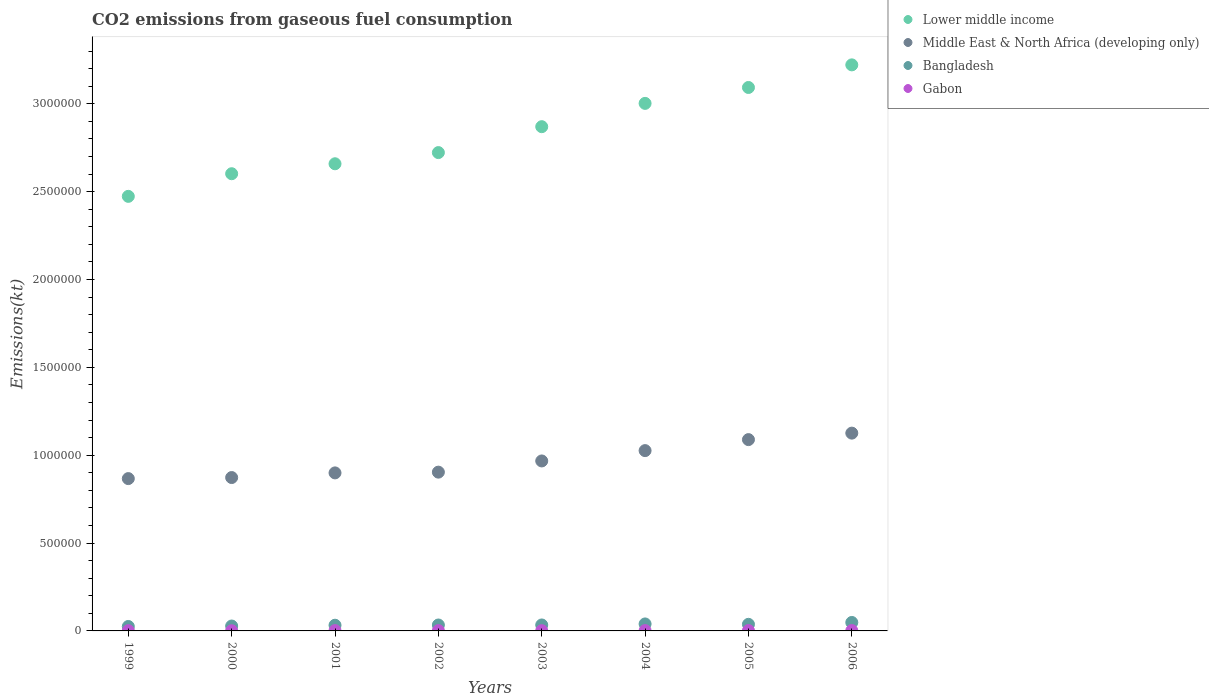Is the number of dotlines equal to the number of legend labels?
Make the answer very short. Yes. What is the amount of CO2 emitted in Bangladesh in 2003?
Your response must be concise. 3.39e+04. Across all years, what is the maximum amount of CO2 emitted in Bangladesh?
Give a very brief answer. 4.81e+04. Across all years, what is the minimum amount of CO2 emitted in Middle East & North Africa (developing only)?
Your response must be concise. 8.67e+05. In which year was the amount of CO2 emitted in Gabon minimum?
Offer a very short reply. 2000. What is the total amount of CO2 emitted in Gabon in the graph?
Give a very brief answer. 1.36e+04. What is the difference between the amount of CO2 emitted in Bangladesh in 1999 and that in 2006?
Your answer should be compact. -2.29e+04. What is the difference between the amount of CO2 emitted in Lower middle income in 2006 and the amount of CO2 emitted in Bangladesh in 2003?
Ensure brevity in your answer.  3.19e+06. What is the average amount of CO2 emitted in Bangladesh per year?
Give a very brief answer. 3.48e+04. In the year 2005, what is the difference between the amount of CO2 emitted in Bangladesh and amount of CO2 emitted in Middle East & North Africa (developing only)?
Offer a terse response. -1.05e+06. What is the ratio of the amount of CO2 emitted in Gabon in 1999 to that in 2004?
Offer a very short reply. 0.78. Is the difference between the amount of CO2 emitted in Bangladesh in 1999 and 2004 greater than the difference between the amount of CO2 emitted in Middle East & North Africa (developing only) in 1999 and 2004?
Provide a succinct answer. Yes. What is the difference between the highest and the second highest amount of CO2 emitted in Bangladesh?
Give a very brief answer. 8386.43. What is the difference between the highest and the lowest amount of CO2 emitted in Lower middle income?
Provide a succinct answer. 7.48e+05. How many years are there in the graph?
Your answer should be compact. 8. What is the difference between two consecutive major ticks on the Y-axis?
Make the answer very short. 5.00e+05. Does the graph contain any zero values?
Offer a very short reply. No. What is the title of the graph?
Provide a succinct answer. CO2 emissions from gaseous fuel consumption. Does "New Zealand" appear as one of the legend labels in the graph?
Your answer should be very brief. No. What is the label or title of the Y-axis?
Provide a short and direct response. Emissions(kt). What is the Emissions(kt) of Lower middle income in 1999?
Your answer should be very brief. 2.47e+06. What is the Emissions(kt) of Middle East & North Africa (developing only) in 1999?
Provide a succinct answer. 8.67e+05. What is the Emissions(kt) in Bangladesh in 1999?
Your answer should be compact. 2.52e+04. What is the Emissions(kt) in Gabon in 1999?
Your response must be concise. 1437.46. What is the Emissions(kt) of Lower middle income in 2000?
Your answer should be compact. 2.60e+06. What is the Emissions(kt) of Middle East & North Africa (developing only) in 2000?
Keep it short and to the point. 8.73e+05. What is the Emissions(kt) in Bangladesh in 2000?
Give a very brief answer. 2.79e+04. What is the Emissions(kt) in Gabon in 2000?
Make the answer very short. 1052.43. What is the Emissions(kt) of Lower middle income in 2001?
Ensure brevity in your answer.  2.66e+06. What is the Emissions(kt) of Middle East & North Africa (developing only) in 2001?
Offer a very short reply. 8.99e+05. What is the Emissions(kt) of Bangladesh in 2001?
Your response must be concise. 3.25e+04. What is the Emissions(kt) in Gabon in 2001?
Provide a succinct answer. 1782.16. What is the Emissions(kt) in Lower middle income in 2002?
Your answer should be compact. 2.72e+06. What is the Emissions(kt) in Middle East & North Africa (developing only) in 2002?
Your answer should be compact. 9.04e+05. What is the Emissions(kt) in Bangladesh in 2002?
Provide a short and direct response. 3.37e+04. What is the Emissions(kt) in Gabon in 2002?
Your answer should be compact. 1778.49. What is the Emissions(kt) in Lower middle income in 2003?
Give a very brief answer. 2.87e+06. What is the Emissions(kt) in Middle East & North Africa (developing only) in 2003?
Keep it short and to the point. 9.67e+05. What is the Emissions(kt) in Bangladesh in 2003?
Your answer should be very brief. 3.39e+04. What is the Emissions(kt) in Gabon in 2003?
Your answer should be very brief. 1441.13. What is the Emissions(kt) of Lower middle income in 2004?
Provide a short and direct response. 3.00e+06. What is the Emissions(kt) of Middle East & North Africa (developing only) in 2004?
Offer a very short reply. 1.03e+06. What is the Emissions(kt) in Bangladesh in 2004?
Your response must be concise. 3.98e+04. What is the Emissions(kt) of Gabon in 2004?
Ensure brevity in your answer.  1851.84. What is the Emissions(kt) in Lower middle income in 2005?
Give a very brief answer. 3.09e+06. What is the Emissions(kt) in Middle East & North Africa (developing only) in 2005?
Ensure brevity in your answer.  1.09e+06. What is the Emissions(kt) in Bangladesh in 2005?
Keep it short and to the point. 3.76e+04. What is the Emissions(kt) in Gabon in 2005?
Give a very brief answer. 2174.53. What is the Emissions(kt) of Lower middle income in 2006?
Offer a very short reply. 3.22e+06. What is the Emissions(kt) in Middle East & North Africa (developing only) in 2006?
Ensure brevity in your answer.  1.13e+06. What is the Emissions(kt) in Bangladesh in 2006?
Provide a succinct answer. 4.81e+04. What is the Emissions(kt) in Gabon in 2006?
Ensure brevity in your answer.  2082.86. Across all years, what is the maximum Emissions(kt) in Lower middle income?
Give a very brief answer. 3.22e+06. Across all years, what is the maximum Emissions(kt) in Middle East & North Africa (developing only)?
Provide a short and direct response. 1.13e+06. Across all years, what is the maximum Emissions(kt) of Bangladesh?
Ensure brevity in your answer.  4.81e+04. Across all years, what is the maximum Emissions(kt) of Gabon?
Your response must be concise. 2174.53. Across all years, what is the minimum Emissions(kt) of Lower middle income?
Offer a very short reply. 2.47e+06. Across all years, what is the minimum Emissions(kt) in Middle East & North Africa (developing only)?
Your answer should be compact. 8.67e+05. Across all years, what is the minimum Emissions(kt) in Bangladesh?
Ensure brevity in your answer.  2.52e+04. Across all years, what is the minimum Emissions(kt) in Gabon?
Offer a terse response. 1052.43. What is the total Emissions(kt) in Lower middle income in the graph?
Make the answer very short. 2.26e+07. What is the total Emissions(kt) in Middle East & North Africa (developing only) in the graph?
Ensure brevity in your answer.  7.75e+06. What is the total Emissions(kt) in Bangladesh in the graph?
Ensure brevity in your answer.  2.79e+05. What is the total Emissions(kt) of Gabon in the graph?
Your answer should be compact. 1.36e+04. What is the difference between the Emissions(kt) of Lower middle income in 1999 and that in 2000?
Ensure brevity in your answer.  -1.29e+05. What is the difference between the Emissions(kt) in Middle East & North Africa (developing only) in 1999 and that in 2000?
Keep it short and to the point. -5958.88. What is the difference between the Emissions(kt) in Bangladesh in 1999 and that in 2000?
Your answer should be very brief. -2632.91. What is the difference between the Emissions(kt) in Gabon in 1999 and that in 2000?
Make the answer very short. 385.04. What is the difference between the Emissions(kt) in Lower middle income in 1999 and that in 2001?
Ensure brevity in your answer.  -1.85e+05. What is the difference between the Emissions(kt) in Middle East & North Africa (developing only) in 1999 and that in 2001?
Your answer should be compact. -3.24e+04. What is the difference between the Emissions(kt) in Bangladesh in 1999 and that in 2001?
Offer a terse response. -7220.32. What is the difference between the Emissions(kt) of Gabon in 1999 and that in 2001?
Give a very brief answer. -344.7. What is the difference between the Emissions(kt) in Lower middle income in 1999 and that in 2002?
Provide a short and direct response. -2.49e+05. What is the difference between the Emissions(kt) of Middle East & North Africa (developing only) in 1999 and that in 2002?
Your answer should be very brief. -3.67e+04. What is the difference between the Emissions(kt) in Bangladesh in 1999 and that in 2002?
Provide a succinct answer. -8470.77. What is the difference between the Emissions(kt) of Gabon in 1999 and that in 2002?
Your answer should be compact. -341.03. What is the difference between the Emissions(kt) of Lower middle income in 1999 and that in 2003?
Offer a very short reply. -3.97e+05. What is the difference between the Emissions(kt) of Middle East & North Africa (developing only) in 1999 and that in 2003?
Provide a short and direct response. -1.00e+05. What is the difference between the Emissions(kt) in Bangladesh in 1999 and that in 2003?
Your response must be concise. -8646.79. What is the difference between the Emissions(kt) in Gabon in 1999 and that in 2003?
Your answer should be compact. -3.67. What is the difference between the Emissions(kt) of Lower middle income in 1999 and that in 2004?
Keep it short and to the point. -5.29e+05. What is the difference between the Emissions(kt) in Middle East & North Africa (developing only) in 1999 and that in 2004?
Provide a succinct answer. -1.59e+05. What is the difference between the Emissions(kt) of Bangladesh in 1999 and that in 2004?
Your response must be concise. -1.45e+04. What is the difference between the Emissions(kt) of Gabon in 1999 and that in 2004?
Your response must be concise. -414.37. What is the difference between the Emissions(kt) of Lower middle income in 1999 and that in 2005?
Provide a short and direct response. -6.20e+05. What is the difference between the Emissions(kt) of Middle East & North Africa (developing only) in 1999 and that in 2005?
Provide a short and direct response. -2.22e+05. What is the difference between the Emissions(kt) of Bangladesh in 1999 and that in 2005?
Give a very brief answer. -1.23e+04. What is the difference between the Emissions(kt) of Gabon in 1999 and that in 2005?
Offer a terse response. -737.07. What is the difference between the Emissions(kt) of Lower middle income in 1999 and that in 2006?
Your answer should be very brief. -7.48e+05. What is the difference between the Emissions(kt) of Middle East & North Africa (developing only) in 1999 and that in 2006?
Offer a very short reply. -2.59e+05. What is the difference between the Emissions(kt) of Bangladesh in 1999 and that in 2006?
Ensure brevity in your answer.  -2.29e+04. What is the difference between the Emissions(kt) in Gabon in 1999 and that in 2006?
Make the answer very short. -645.39. What is the difference between the Emissions(kt) of Lower middle income in 2000 and that in 2001?
Your answer should be compact. -5.67e+04. What is the difference between the Emissions(kt) in Middle East & North Africa (developing only) in 2000 and that in 2001?
Provide a succinct answer. -2.65e+04. What is the difference between the Emissions(kt) in Bangladesh in 2000 and that in 2001?
Your answer should be compact. -4587.42. What is the difference between the Emissions(kt) of Gabon in 2000 and that in 2001?
Make the answer very short. -729.73. What is the difference between the Emissions(kt) in Lower middle income in 2000 and that in 2002?
Make the answer very short. -1.20e+05. What is the difference between the Emissions(kt) in Middle East & North Africa (developing only) in 2000 and that in 2002?
Provide a succinct answer. -3.08e+04. What is the difference between the Emissions(kt) in Bangladesh in 2000 and that in 2002?
Give a very brief answer. -5837.86. What is the difference between the Emissions(kt) in Gabon in 2000 and that in 2002?
Give a very brief answer. -726.07. What is the difference between the Emissions(kt) in Lower middle income in 2000 and that in 2003?
Your answer should be compact. -2.68e+05. What is the difference between the Emissions(kt) of Middle East & North Africa (developing only) in 2000 and that in 2003?
Make the answer very short. -9.45e+04. What is the difference between the Emissions(kt) of Bangladesh in 2000 and that in 2003?
Provide a short and direct response. -6013.88. What is the difference between the Emissions(kt) of Gabon in 2000 and that in 2003?
Ensure brevity in your answer.  -388.7. What is the difference between the Emissions(kt) in Lower middle income in 2000 and that in 2004?
Give a very brief answer. -4.00e+05. What is the difference between the Emissions(kt) of Middle East & North Africa (developing only) in 2000 and that in 2004?
Provide a succinct answer. -1.53e+05. What is the difference between the Emissions(kt) of Bangladesh in 2000 and that in 2004?
Offer a very short reply. -1.19e+04. What is the difference between the Emissions(kt) of Gabon in 2000 and that in 2004?
Make the answer very short. -799.41. What is the difference between the Emissions(kt) of Lower middle income in 2000 and that in 2005?
Keep it short and to the point. -4.91e+05. What is the difference between the Emissions(kt) of Middle East & North Africa (developing only) in 2000 and that in 2005?
Your answer should be very brief. -2.16e+05. What is the difference between the Emissions(kt) of Bangladesh in 2000 and that in 2005?
Keep it short and to the point. -9684.55. What is the difference between the Emissions(kt) in Gabon in 2000 and that in 2005?
Your answer should be compact. -1122.1. What is the difference between the Emissions(kt) of Lower middle income in 2000 and that in 2006?
Ensure brevity in your answer.  -6.20e+05. What is the difference between the Emissions(kt) in Middle East & North Africa (developing only) in 2000 and that in 2006?
Offer a terse response. -2.53e+05. What is the difference between the Emissions(kt) of Bangladesh in 2000 and that in 2006?
Ensure brevity in your answer.  -2.03e+04. What is the difference between the Emissions(kt) in Gabon in 2000 and that in 2006?
Keep it short and to the point. -1030.43. What is the difference between the Emissions(kt) in Lower middle income in 2001 and that in 2002?
Your answer should be compact. -6.36e+04. What is the difference between the Emissions(kt) of Middle East & North Africa (developing only) in 2001 and that in 2002?
Offer a very short reply. -4283.06. What is the difference between the Emissions(kt) of Bangladesh in 2001 and that in 2002?
Ensure brevity in your answer.  -1250.45. What is the difference between the Emissions(kt) of Gabon in 2001 and that in 2002?
Your answer should be very brief. 3.67. What is the difference between the Emissions(kt) of Lower middle income in 2001 and that in 2003?
Keep it short and to the point. -2.11e+05. What is the difference between the Emissions(kt) in Middle East & North Africa (developing only) in 2001 and that in 2003?
Your answer should be compact. -6.80e+04. What is the difference between the Emissions(kt) in Bangladesh in 2001 and that in 2003?
Keep it short and to the point. -1426.46. What is the difference between the Emissions(kt) in Gabon in 2001 and that in 2003?
Ensure brevity in your answer.  341.03. What is the difference between the Emissions(kt) of Lower middle income in 2001 and that in 2004?
Offer a terse response. -3.44e+05. What is the difference between the Emissions(kt) in Middle East & North Africa (developing only) in 2001 and that in 2004?
Your answer should be compact. -1.27e+05. What is the difference between the Emissions(kt) of Bangladesh in 2001 and that in 2004?
Your response must be concise. -7293.66. What is the difference between the Emissions(kt) of Gabon in 2001 and that in 2004?
Provide a short and direct response. -69.67. What is the difference between the Emissions(kt) in Lower middle income in 2001 and that in 2005?
Your response must be concise. -4.34e+05. What is the difference between the Emissions(kt) in Middle East & North Africa (developing only) in 2001 and that in 2005?
Offer a terse response. -1.89e+05. What is the difference between the Emissions(kt) in Bangladesh in 2001 and that in 2005?
Your answer should be compact. -5097.13. What is the difference between the Emissions(kt) in Gabon in 2001 and that in 2005?
Make the answer very short. -392.37. What is the difference between the Emissions(kt) of Lower middle income in 2001 and that in 2006?
Your answer should be compact. -5.63e+05. What is the difference between the Emissions(kt) in Middle East & North Africa (developing only) in 2001 and that in 2006?
Make the answer very short. -2.26e+05. What is the difference between the Emissions(kt) in Bangladesh in 2001 and that in 2006?
Give a very brief answer. -1.57e+04. What is the difference between the Emissions(kt) of Gabon in 2001 and that in 2006?
Your answer should be compact. -300.69. What is the difference between the Emissions(kt) in Lower middle income in 2002 and that in 2003?
Your answer should be very brief. -1.47e+05. What is the difference between the Emissions(kt) of Middle East & North Africa (developing only) in 2002 and that in 2003?
Make the answer very short. -6.37e+04. What is the difference between the Emissions(kt) in Bangladesh in 2002 and that in 2003?
Provide a short and direct response. -176.02. What is the difference between the Emissions(kt) in Gabon in 2002 and that in 2003?
Ensure brevity in your answer.  337.36. What is the difference between the Emissions(kt) of Lower middle income in 2002 and that in 2004?
Provide a short and direct response. -2.80e+05. What is the difference between the Emissions(kt) in Middle East & North Africa (developing only) in 2002 and that in 2004?
Your response must be concise. -1.23e+05. What is the difference between the Emissions(kt) in Bangladesh in 2002 and that in 2004?
Offer a very short reply. -6043.22. What is the difference between the Emissions(kt) in Gabon in 2002 and that in 2004?
Make the answer very short. -73.34. What is the difference between the Emissions(kt) in Lower middle income in 2002 and that in 2005?
Your answer should be very brief. -3.71e+05. What is the difference between the Emissions(kt) in Middle East & North Africa (developing only) in 2002 and that in 2005?
Your answer should be very brief. -1.85e+05. What is the difference between the Emissions(kt) in Bangladesh in 2002 and that in 2005?
Your answer should be very brief. -3846.68. What is the difference between the Emissions(kt) in Gabon in 2002 and that in 2005?
Make the answer very short. -396.04. What is the difference between the Emissions(kt) of Lower middle income in 2002 and that in 2006?
Make the answer very short. -4.99e+05. What is the difference between the Emissions(kt) in Middle East & North Africa (developing only) in 2002 and that in 2006?
Make the answer very short. -2.22e+05. What is the difference between the Emissions(kt) of Bangladesh in 2002 and that in 2006?
Provide a short and direct response. -1.44e+04. What is the difference between the Emissions(kt) of Gabon in 2002 and that in 2006?
Make the answer very short. -304.36. What is the difference between the Emissions(kt) of Lower middle income in 2003 and that in 2004?
Offer a terse response. -1.33e+05. What is the difference between the Emissions(kt) of Middle East & North Africa (developing only) in 2003 and that in 2004?
Offer a terse response. -5.88e+04. What is the difference between the Emissions(kt) in Bangladesh in 2003 and that in 2004?
Keep it short and to the point. -5867.2. What is the difference between the Emissions(kt) of Gabon in 2003 and that in 2004?
Make the answer very short. -410.7. What is the difference between the Emissions(kt) in Lower middle income in 2003 and that in 2005?
Offer a very short reply. -2.23e+05. What is the difference between the Emissions(kt) in Middle East & North Africa (developing only) in 2003 and that in 2005?
Provide a succinct answer. -1.21e+05. What is the difference between the Emissions(kt) in Bangladesh in 2003 and that in 2005?
Your response must be concise. -3670.67. What is the difference between the Emissions(kt) of Gabon in 2003 and that in 2005?
Keep it short and to the point. -733.4. What is the difference between the Emissions(kt) in Lower middle income in 2003 and that in 2006?
Give a very brief answer. -3.52e+05. What is the difference between the Emissions(kt) in Middle East & North Africa (developing only) in 2003 and that in 2006?
Keep it short and to the point. -1.58e+05. What is the difference between the Emissions(kt) in Bangladesh in 2003 and that in 2006?
Keep it short and to the point. -1.43e+04. What is the difference between the Emissions(kt) in Gabon in 2003 and that in 2006?
Give a very brief answer. -641.73. What is the difference between the Emissions(kt) in Lower middle income in 2004 and that in 2005?
Provide a short and direct response. -9.05e+04. What is the difference between the Emissions(kt) of Middle East & North Africa (developing only) in 2004 and that in 2005?
Give a very brief answer. -6.26e+04. What is the difference between the Emissions(kt) in Bangladesh in 2004 and that in 2005?
Offer a very short reply. 2196.53. What is the difference between the Emissions(kt) in Gabon in 2004 and that in 2005?
Make the answer very short. -322.7. What is the difference between the Emissions(kt) in Lower middle income in 2004 and that in 2006?
Your answer should be very brief. -2.19e+05. What is the difference between the Emissions(kt) in Middle East & North Africa (developing only) in 2004 and that in 2006?
Offer a terse response. -9.95e+04. What is the difference between the Emissions(kt) in Bangladesh in 2004 and that in 2006?
Offer a terse response. -8386.43. What is the difference between the Emissions(kt) of Gabon in 2004 and that in 2006?
Your response must be concise. -231.02. What is the difference between the Emissions(kt) in Lower middle income in 2005 and that in 2006?
Your answer should be very brief. -1.29e+05. What is the difference between the Emissions(kt) in Middle East & North Africa (developing only) in 2005 and that in 2006?
Keep it short and to the point. -3.69e+04. What is the difference between the Emissions(kt) of Bangladesh in 2005 and that in 2006?
Offer a very short reply. -1.06e+04. What is the difference between the Emissions(kt) of Gabon in 2005 and that in 2006?
Offer a terse response. 91.67. What is the difference between the Emissions(kt) in Lower middle income in 1999 and the Emissions(kt) in Middle East & North Africa (developing only) in 2000?
Make the answer very short. 1.60e+06. What is the difference between the Emissions(kt) of Lower middle income in 1999 and the Emissions(kt) of Bangladesh in 2000?
Your answer should be very brief. 2.45e+06. What is the difference between the Emissions(kt) in Lower middle income in 1999 and the Emissions(kt) in Gabon in 2000?
Your response must be concise. 2.47e+06. What is the difference between the Emissions(kt) in Middle East & North Africa (developing only) in 1999 and the Emissions(kt) in Bangladesh in 2000?
Offer a terse response. 8.39e+05. What is the difference between the Emissions(kt) of Middle East & North Africa (developing only) in 1999 and the Emissions(kt) of Gabon in 2000?
Give a very brief answer. 8.66e+05. What is the difference between the Emissions(kt) in Bangladesh in 1999 and the Emissions(kt) in Gabon in 2000?
Keep it short and to the point. 2.42e+04. What is the difference between the Emissions(kt) in Lower middle income in 1999 and the Emissions(kt) in Middle East & North Africa (developing only) in 2001?
Ensure brevity in your answer.  1.57e+06. What is the difference between the Emissions(kt) in Lower middle income in 1999 and the Emissions(kt) in Bangladesh in 2001?
Your response must be concise. 2.44e+06. What is the difference between the Emissions(kt) of Lower middle income in 1999 and the Emissions(kt) of Gabon in 2001?
Your answer should be very brief. 2.47e+06. What is the difference between the Emissions(kt) of Middle East & North Africa (developing only) in 1999 and the Emissions(kt) of Bangladesh in 2001?
Your response must be concise. 8.35e+05. What is the difference between the Emissions(kt) in Middle East & North Africa (developing only) in 1999 and the Emissions(kt) in Gabon in 2001?
Provide a succinct answer. 8.65e+05. What is the difference between the Emissions(kt) of Bangladesh in 1999 and the Emissions(kt) of Gabon in 2001?
Provide a succinct answer. 2.35e+04. What is the difference between the Emissions(kt) in Lower middle income in 1999 and the Emissions(kt) in Middle East & North Africa (developing only) in 2002?
Keep it short and to the point. 1.57e+06. What is the difference between the Emissions(kt) in Lower middle income in 1999 and the Emissions(kt) in Bangladesh in 2002?
Give a very brief answer. 2.44e+06. What is the difference between the Emissions(kt) in Lower middle income in 1999 and the Emissions(kt) in Gabon in 2002?
Offer a very short reply. 2.47e+06. What is the difference between the Emissions(kt) in Middle East & North Africa (developing only) in 1999 and the Emissions(kt) in Bangladesh in 2002?
Offer a terse response. 8.33e+05. What is the difference between the Emissions(kt) of Middle East & North Africa (developing only) in 1999 and the Emissions(kt) of Gabon in 2002?
Provide a short and direct response. 8.65e+05. What is the difference between the Emissions(kt) of Bangladesh in 1999 and the Emissions(kt) of Gabon in 2002?
Make the answer very short. 2.35e+04. What is the difference between the Emissions(kt) of Lower middle income in 1999 and the Emissions(kt) of Middle East & North Africa (developing only) in 2003?
Offer a very short reply. 1.51e+06. What is the difference between the Emissions(kt) in Lower middle income in 1999 and the Emissions(kt) in Bangladesh in 2003?
Provide a succinct answer. 2.44e+06. What is the difference between the Emissions(kt) of Lower middle income in 1999 and the Emissions(kt) of Gabon in 2003?
Provide a short and direct response. 2.47e+06. What is the difference between the Emissions(kt) in Middle East & North Africa (developing only) in 1999 and the Emissions(kt) in Bangladesh in 2003?
Make the answer very short. 8.33e+05. What is the difference between the Emissions(kt) of Middle East & North Africa (developing only) in 1999 and the Emissions(kt) of Gabon in 2003?
Your response must be concise. 8.66e+05. What is the difference between the Emissions(kt) of Bangladesh in 1999 and the Emissions(kt) of Gabon in 2003?
Provide a short and direct response. 2.38e+04. What is the difference between the Emissions(kt) in Lower middle income in 1999 and the Emissions(kt) in Middle East & North Africa (developing only) in 2004?
Give a very brief answer. 1.45e+06. What is the difference between the Emissions(kt) in Lower middle income in 1999 and the Emissions(kt) in Bangladesh in 2004?
Make the answer very short. 2.43e+06. What is the difference between the Emissions(kt) of Lower middle income in 1999 and the Emissions(kt) of Gabon in 2004?
Your answer should be very brief. 2.47e+06. What is the difference between the Emissions(kt) of Middle East & North Africa (developing only) in 1999 and the Emissions(kt) of Bangladesh in 2004?
Provide a succinct answer. 8.27e+05. What is the difference between the Emissions(kt) in Middle East & North Africa (developing only) in 1999 and the Emissions(kt) in Gabon in 2004?
Your answer should be compact. 8.65e+05. What is the difference between the Emissions(kt) in Bangladesh in 1999 and the Emissions(kt) in Gabon in 2004?
Your answer should be very brief. 2.34e+04. What is the difference between the Emissions(kt) in Lower middle income in 1999 and the Emissions(kt) in Middle East & North Africa (developing only) in 2005?
Offer a terse response. 1.38e+06. What is the difference between the Emissions(kt) of Lower middle income in 1999 and the Emissions(kt) of Bangladesh in 2005?
Provide a short and direct response. 2.44e+06. What is the difference between the Emissions(kt) in Lower middle income in 1999 and the Emissions(kt) in Gabon in 2005?
Provide a succinct answer. 2.47e+06. What is the difference between the Emissions(kt) of Middle East & North Africa (developing only) in 1999 and the Emissions(kt) of Bangladesh in 2005?
Offer a terse response. 8.29e+05. What is the difference between the Emissions(kt) of Middle East & North Africa (developing only) in 1999 and the Emissions(kt) of Gabon in 2005?
Ensure brevity in your answer.  8.65e+05. What is the difference between the Emissions(kt) of Bangladesh in 1999 and the Emissions(kt) of Gabon in 2005?
Provide a succinct answer. 2.31e+04. What is the difference between the Emissions(kt) in Lower middle income in 1999 and the Emissions(kt) in Middle East & North Africa (developing only) in 2006?
Provide a short and direct response. 1.35e+06. What is the difference between the Emissions(kt) of Lower middle income in 1999 and the Emissions(kt) of Bangladesh in 2006?
Your response must be concise. 2.43e+06. What is the difference between the Emissions(kt) of Lower middle income in 1999 and the Emissions(kt) of Gabon in 2006?
Make the answer very short. 2.47e+06. What is the difference between the Emissions(kt) in Middle East & North Africa (developing only) in 1999 and the Emissions(kt) in Bangladesh in 2006?
Your answer should be very brief. 8.19e+05. What is the difference between the Emissions(kt) of Middle East & North Africa (developing only) in 1999 and the Emissions(kt) of Gabon in 2006?
Offer a very short reply. 8.65e+05. What is the difference between the Emissions(kt) of Bangladesh in 1999 and the Emissions(kt) of Gabon in 2006?
Give a very brief answer. 2.32e+04. What is the difference between the Emissions(kt) in Lower middle income in 2000 and the Emissions(kt) in Middle East & North Africa (developing only) in 2001?
Make the answer very short. 1.70e+06. What is the difference between the Emissions(kt) in Lower middle income in 2000 and the Emissions(kt) in Bangladesh in 2001?
Your answer should be compact. 2.57e+06. What is the difference between the Emissions(kt) of Lower middle income in 2000 and the Emissions(kt) of Gabon in 2001?
Offer a terse response. 2.60e+06. What is the difference between the Emissions(kt) of Middle East & North Africa (developing only) in 2000 and the Emissions(kt) of Bangladesh in 2001?
Ensure brevity in your answer.  8.41e+05. What is the difference between the Emissions(kt) in Middle East & North Africa (developing only) in 2000 and the Emissions(kt) in Gabon in 2001?
Provide a succinct answer. 8.71e+05. What is the difference between the Emissions(kt) in Bangladesh in 2000 and the Emissions(kt) in Gabon in 2001?
Keep it short and to the point. 2.61e+04. What is the difference between the Emissions(kt) of Lower middle income in 2000 and the Emissions(kt) of Middle East & North Africa (developing only) in 2002?
Keep it short and to the point. 1.70e+06. What is the difference between the Emissions(kt) in Lower middle income in 2000 and the Emissions(kt) in Bangladesh in 2002?
Ensure brevity in your answer.  2.57e+06. What is the difference between the Emissions(kt) of Lower middle income in 2000 and the Emissions(kt) of Gabon in 2002?
Ensure brevity in your answer.  2.60e+06. What is the difference between the Emissions(kt) in Middle East & North Africa (developing only) in 2000 and the Emissions(kt) in Bangladesh in 2002?
Keep it short and to the point. 8.39e+05. What is the difference between the Emissions(kt) of Middle East & North Africa (developing only) in 2000 and the Emissions(kt) of Gabon in 2002?
Provide a short and direct response. 8.71e+05. What is the difference between the Emissions(kt) of Bangladesh in 2000 and the Emissions(kt) of Gabon in 2002?
Keep it short and to the point. 2.61e+04. What is the difference between the Emissions(kt) of Lower middle income in 2000 and the Emissions(kt) of Middle East & North Africa (developing only) in 2003?
Your answer should be compact. 1.63e+06. What is the difference between the Emissions(kt) in Lower middle income in 2000 and the Emissions(kt) in Bangladesh in 2003?
Your response must be concise. 2.57e+06. What is the difference between the Emissions(kt) in Lower middle income in 2000 and the Emissions(kt) in Gabon in 2003?
Your response must be concise. 2.60e+06. What is the difference between the Emissions(kt) in Middle East & North Africa (developing only) in 2000 and the Emissions(kt) in Bangladesh in 2003?
Give a very brief answer. 8.39e+05. What is the difference between the Emissions(kt) of Middle East & North Africa (developing only) in 2000 and the Emissions(kt) of Gabon in 2003?
Offer a very short reply. 8.72e+05. What is the difference between the Emissions(kt) of Bangladesh in 2000 and the Emissions(kt) of Gabon in 2003?
Make the answer very short. 2.64e+04. What is the difference between the Emissions(kt) in Lower middle income in 2000 and the Emissions(kt) in Middle East & North Africa (developing only) in 2004?
Give a very brief answer. 1.58e+06. What is the difference between the Emissions(kt) of Lower middle income in 2000 and the Emissions(kt) of Bangladesh in 2004?
Your response must be concise. 2.56e+06. What is the difference between the Emissions(kt) in Lower middle income in 2000 and the Emissions(kt) in Gabon in 2004?
Your answer should be very brief. 2.60e+06. What is the difference between the Emissions(kt) of Middle East & North Africa (developing only) in 2000 and the Emissions(kt) of Bangladesh in 2004?
Your response must be concise. 8.33e+05. What is the difference between the Emissions(kt) of Middle East & North Africa (developing only) in 2000 and the Emissions(kt) of Gabon in 2004?
Your answer should be very brief. 8.71e+05. What is the difference between the Emissions(kt) of Bangladesh in 2000 and the Emissions(kt) of Gabon in 2004?
Give a very brief answer. 2.60e+04. What is the difference between the Emissions(kt) of Lower middle income in 2000 and the Emissions(kt) of Middle East & North Africa (developing only) in 2005?
Offer a very short reply. 1.51e+06. What is the difference between the Emissions(kt) in Lower middle income in 2000 and the Emissions(kt) in Bangladesh in 2005?
Ensure brevity in your answer.  2.56e+06. What is the difference between the Emissions(kt) of Lower middle income in 2000 and the Emissions(kt) of Gabon in 2005?
Your answer should be very brief. 2.60e+06. What is the difference between the Emissions(kt) in Middle East & North Africa (developing only) in 2000 and the Emissions(kt) in Bangladesh in 2005?
Make the answer very short. 8.35e+05. What is the difference between the Emissions(kt) in Middle East & North Africa (developing only) in 2000 and the Emissions(kt) in Gabon in 2005?
Provide a short and direct response. 8.71e+05. What is the difference between the Emissions(kt) in Bangladesh in 2000 and the Emissions(kt) in Gabon in 2005?
Keep it short and to the point. 2.57e+04. What is the difference between the Emissions(kt) of Lower middle income in 2000 and the Emissions(kt) of Middle East & North Africa (developing only) in 2006?
Offer a terse response. 1.48e+06. What is the difference between the Emissions(kt) in Lower middle income in 2000 and the Emissions(kt) in Bangladesh in 2006?
Your response must be concise. 2.55e+06. What is the difference between the Emissions(kt) in Lower middle income in 2000 and the Emissions(kt) in Gabon in 2006?
Provide a short and direct response. 2.60e+06. What is the difference between the Emissions(kt) of Middle East & North Africa (developing only) in 2000 and the Emissions(kt) of Bangladesh in 2006?
Offer a very short reply. 8.25e+05. What is the difference between the Emissions(kt) in Middle East & North Africa (developing only) in 2000 and the Emissions(kt) in Gabon in 2006?
Keep it short and to the point. 8.71e+05. What is the difference between the Emissions(kt) of Bangladesh in 2000 and the Emissions(kt) of Gabon in 2006?
Your response must be concise. 2.58e+04. What is the difference between the Emissions(kt) in Lower middle income in 2001 and the Emissions(kt) in Middle East & North Africa (developing only) in 2002?
Provide a succinct answer. 1.76e+06. What is the difference between the Emissions(kt) of Lower middle income in 2001 and the Emissions(kt) of Bangladesh in 2002?
Offer a terse response. 2.63e+06. What is the difference between the Emissions(kt) in Lower middle income in 2001 and the Emissions(kt) in Gabon in 2002?
Your response must be concise. 2.66e+06. What is the difference between the Emissions(kt) in Middle East & North Africa (developing only) in 2001 and the Emissions(kt) in Bangladesh in 2002?
Your answer should be very brief. 8.66e+05. What is the difference between the Emissions(kt) of Middle East & North Africa (developing only) in 2001 and the Emissions(kt) of Gabon in 2002?
Offer a terse response. 8.98e+05. What is the difference between the Emissions(kt) of Bangladesh in 2001 and the Emissions(kt) of Gabon in 2002?
Provide a short and direct response. 3.07e+04. What is the difference between the Emissions(kt) of Lower middle income in 2001 and the Emissions(kt) of Middle East & North Africa (developing only) in 2003?
Your response must be concise. 1.69e+06. What is the difference between the Emissions(kt) in Lower middle income in 2001 and the Emissions(kt) in Bangladesh in 2003?
Give a very brief answer. 2.63e+06. What is the difference between the Emissions(kt) of Lower middle income in 2001 and the Emissions(kt) of Gabon in 2003?
Your answer should be compact. 2.66e+06. What is the difference between the Emissions(kt) in Middle East & North Africa (developing only) in 2001 and the Emissions(kt) in Bangladesh in 2003?
Keep it short and to the point. 8.66e+05. What is the difference between the Emissions(kt) of Middle East & North Africa (developing only) in 2001 and the Emissions(kt) of Gabon in 2003?
Provide a succinct answer. 8.98e+05. What is the difference between the Emissions(kt) in Bangladesh in 2001 and the Emissions(kt) in Gabon in 2003?
Provide a short and direct response. 3.10e+04. What is the difference between the Emissions(kt) of Lower middle income in 2001 and the Emissions(kt) of Middle East & North Africa (developing only) in 2004?
Your response must be concise. 1.63e+06. What is the difference between the Emissions(kt) of Lower middle income in 2001 and the Emissions(kt) of Bangladesh in 2004?
Provide a succinct answer. 2.62e+06. What is the difference between the Emissions(kt) of Lower middle income in 2001 and the Emissions(kt) of Gabon in 2004?
Provide a short and direct response. 2.66e+06. What is the difference between the Emissions(kt) of Middle East & North Africa (developing only) in 2001 and the Emissions(kt) of Bangladesh in 2004?
Ensure brevity in your answer.  8.60e+05. What is the difference between the Emissions(kt) of Middle East & North Africa (developing only) in 2001 and the Emissions(kt) of Gabon in 2004?
Make the answer very short. 8.98e+05. What is the difference between the Emissions(kt) of Bangladesh in 2001 and the Emissions(kt) of Gabon in 2004?
Your answer should be very brief. 3.06e+04. What is the difference between the Emissions(kt) of Lower middle income in 2001 and the Emissions(kt) of Middle East & North Africa (developing only) in 2005?
Your answer should be very brief. 1.57e+06. What is the difference between the Emissions(kt) in Lower middle income in 2001 and the Emissions(kt) in Bangladesh in 2005?
Your response must be concise. 2.62e+06. What is the difference between the Emissions(kt) of Lower middle income in 2001 and the Emissions(kt) of Gabon in 2005?
Your response must be concise. 2.66e+06. What is the difference between the Emissions(kt) in Middle East & North Africa (developing only) in 2001 and the Emissions(kt) in Bangladesh in 2005?
Offer a very short reply. 8.62e+05. What is the difference between the Emissions(kt) in Middle East & North Africa (developing only) in 2001 and the Emissions(kt) in Gabon in 2005?
Ensure brevity in your answer.  8.97e+05. What is the difference between the Emissions(kt) of Bangladesh in 2001 and the Emissions(kt) of Gabon in 2005?
Your answer should be compact. 3.03e+04. What is the difference between the Emissions(kt) in Lower middle income in 2001 and the Emissions(kt) in Middle East & North Africa (developing only) in 2006?
Your answer should be compact. 1.53e+06. What is the difference between the Emissions(kt) of Lower middle income in 2001 and the Emissions(kt) of Bangladesh in 2006?
Your response must be concise. 2.61e+06. What is the difference between the Emissions(kt) in Lower middle income in 2001 and the Emissions(kt) in Gabon in 2006?
Your response must be concise. 2.66e+06. What is the difference between the Emissions(kt) in Middle East & North Africa (developing only) in 2001 and the Emissions(kt) in Bangladesh in 2006?
Ensure brevity in your answer.  8.51e+05. What is the difference between the Emissions(kt) of Middle East & North Africa (developing only) in 2001 and the Emissions(kt) of Gabon in 2006?
Your answer should be compact. 8.97e+05. What is the difference between the Emissions(kt) in Bangladesh in 2001 and the Emissions(kt) in Gabon in 2006?
Your answer should be compact. 3.04e+04. What is the difference between the Emissions(kt) of Lower middle income in 2002 and the Emissions(kt) of Middle East & North Africa (developing only) in 2003?
Keep it short and to the point. 1.76e+06. What is the difference between the Emissions(kt) of Lower middle income in 2002 and the Emissions(kt) of Bangladesh in 2003?
Keep it short and to the point. 2.69e+06. What is the difference between the Emissions(kt) in Lower middle income in 2002 and the Emissions(kt) in Gabon in 2003?
Offer a terse response. 2.72e+06. What is the difference between the Emissions(kt) in Middle East & North Africa (developing only) in 2002 and the Emissions(kt) in Bangladesh in 2003?
Your answer should be compact. 8.70e+05. What is the difference between the Emissions(kt) in Middle East & North Africa (developing only) in 2002 and the Emissions(kt) in Gabon in 2003?
Your answer should be compact. 9.02e+05. What is the difference between the Emissions(kt) in Bangladesh in 2002 and the Emissions(kt) in Gabon in 2003?
Ensure brevity in your answer.  3.23e+04. What is the difference between the Emissions(kt) in Lower middle income in 2002 and the Emissions(kt) in Middle East & North Africa (developing only) in 2004?
Provide a short and direct response. 1.70e+06. What is the difference between the Emissions(kt) in Lower middle income in 2002 and the Emissions(kt) in Bangladesh in 2004?
Offer a terse response. 2.68e+06. What is the difference between the Emissions(kt) in Lower middle income in 2002 and the Emissions(kt) in Gabon in 2004?
Offer a terse response. 2.72e+06. What is the difference between the Emissions(kt) of Middle East & North Africa (developing only) in 2002 and the Emissions(kt) of Bangladesh in 2004?
Your answer should be very brief. 8.64e+05. What is the difference between the Emissions(kt) in Middle East & North Africa (developing only) in 2002 and the Emissions(kt) in Gabon in 2004?
Make the answer very short. 9.02e+05. What is the difference between the Emissions(kt) of Bangladesh in 2002 and the Emissions(kt) of Gabon in 2004?
Your response must be concise. 3.19e+04. What is the difference between the Emissions(kt) in Lower middle income in 2002 and the Emissions(kt) in Middle East & North Africa (developing only) in 2005?
Make the answer very short. 1.63e+06. What is the difference between the Emissions(kt) of Lower middle income in 2002 and the Emissions(kt) of Bangladesh in 2005?
Make the answer very short. 2.69e+06. What is the difference between the Emissions(kt) of Lower middle income in 2002 and the Emissions(kt) of Gabon in 2005?
Offer a terse response. 2.72e+06. What is the difference between the Emissions(kt) in Middle East & North Africa (developing only) in 2002 and the Emissions(kt) in Bangladesh in 2005?
Give a very brief answer. 8.66e+05. What is the difference between the Emissions(kt) of Middle East & North Africa (developing only) in 2002 and the Emissions(kt) of Gabon in 2005?
Keep it short and to the point. 9.02e+05. What is the difference between the Emissions(kt) of Bangladesh in 2002 and the Emissions(kt) of Gabon in 2005?
Provide a short and direct response. 3.15e+04. What is the difference between the Emissions(kt) of Lower middle income in 2002 and the Emissions(kt) of Middle East & North Africa (developing only) in 2006?
Your response must be concise. 1.60e+06. What is the difference between the Emissions(kt) in Lower middle income in 2002 and the Emissions(kt) in Bangladesh in 2006?
Make the answer very short. 2.67e+06. What is the difference between the Emissions(kt) of Lower middle income in 2002 and the Emissions(kt) of Gabon in 2006?
Give a very brief answer. 2.72e+06. What is the difference between the Emissions(kt) of Middle East & North Africa (developing only) in 2002 and the Emissions(kt) of Bangladesh in 2006?
Your answer should be compact. 8.56e+05. What is the difference between the Emissions(kt) in Middle East & North Africa (developing only) in 2002 and the Emissions(kt) in Gabon in 2006?
Provide a succinct answer. 9.02e+05. What is the difference between the Emissions(kt) of Bangladesh in 2002 and the Emissions(kt) of Gabon in 2006?
Keep it short and to the point. 3.16e+04. What is the difference between the Emissions(kt) of Lower middle income in 2003 and the Emissions(kt) of Middle East & North Africa (developing only) in 2004?
Your response must be concise. 1.84e+06. What is the difference between the Emissions(kt) of Lower middle income in 2003 and the Emissions(kt) of Bangladesh in 2004?
Offer a very short reply. 2.83e+06. What is the difference between the Emissions(kt) of Lower middle income in 2003 and the Emissions(kt) of Gabon in 2004?
Your response must be concise. 2.87e+06. What is the difference between the Emissions(kt) in Middle East & North Africa (developing only) in 2003 and the Emissions(kt) in Bangladesh in 2004?
Keep it short and to the point. 9.28e+05. What is the difference between the Emissions(kt) of Middle East & North Africa (developing only) in 2003 and the Emissions(kt) of Gabon in 2004?
Ensure brevity in your answer.  9.66e+05. What is the difference between the Emissions(kt) in Bangladesh in 2003 and the Emissions(kt) in Gabon in 2004?
Provide a succinct answer. 3.20e+04. What is the difference between the Emissions(kt) in Lower middle income in 2003 and the Emissions(kt) in Middle East & North Africa (developing only) in 2005?
Your answer should be very brief. 1.78e+06. What is the difference between the Emissions(kt) of Lower middle income in 2003 and the Emissions(kt) of Bangladesh in 2005?
Offer a terse response. 2.83e+06. What is the difference between the Emissions(kt) of Lower middle income in 2003 and the Emissions(kt) of Gabon in 2005?
Ensure brevity in your answer.  2.87e+06. What is the difference between the Emissions(kt) in Middle East & North Africa (developing only) in 2003 and the Emissions(kt) in Bangladesh in 2005?
Give a very brief answer. 9.30e+05. What is the difference between the Emissions(kt) of Middle East & North Africa (developing only) in 2003 and the Emissions(kt) of Gabon in 2005?
Ensure brevity in your answer.  9.65e+05. What is the difference between the Emissions(kt) in Bangladesh in 2003 and the Emissions(kt) in Gabon in 2005?
Provide a short and direct response. 3.17e+04. What is the difference between the Emissions(kt) of Lower middle income in 2003 and the Emissions(kt) of Middle East & North Africa (developing only) in 2006?
Provide a short and direct response. 1.74e+06. What is the difference between the Emissions(kt) of Lower middle income in 2003 and the Emissions(kt) of Bangladesh in 2006?
Your answer should be very brief. 2.82e+06. What is the difference between the Emissions(kt) of Lower middle income in 2003 and the Emissions(kt) of Gabon in 2006?
Ensure brevity in your answer.  2.87e+06. What is the difference between the Emissions(kt) of Middle East & North Africa (developing only) in 2003 and the Emissions(kt) of Bangladesh in 2006?
Offer a terse response. 9.19e+05. What is the difference between the Emissions(kt) in Middle East & North Africa (developing only) in 2003 and the Emissions(kt) in Gabon in 2006?
Make the answer very short. 9.65e+05. What is the difference between the Emissions(kt) of Bangladesh in 2003 and the Emissions(kt) of Gabon in 2006?
Your answer should be compact. 3.18e+04. What is the difference between the Emissions(kt) of Lower middle income in 2004 and the Emissions(kt) of Middle East & North Africa (developing only) in 2005?
Ensure brevity in your answer.  1.91e+06. What is the difference between the Emissions(kt) in Lower middle income in 2004 and the Emissions(kt) in Bangladesh in 2005?
Keep it short and to the point. 2.97e+06. What is the difference between the Emissions(kt) in Lower middle income in 2004 and the Emissions(kt) in Gabon in 2005?
Your answer should be very brief. 3.00e+06. What is the difference between the Emissions(kt) of Middle East & North Africa (developing only) in 2004 and the Emissions(kt) of Bangladesh in 2005?
Make the answer very short. 9.89e+05. What is the difference between the Emissions(kt) of Middle East & North Africa (developing only) in 2004 and the Emissions(kt) of Gabon in 2005?
Make the answer very short. 1.02e+06. What is the difference between the Emissions(kt) of Bangladesh in 2004 and the Emissions(kt) of Gabon in 2005?
Provide a short and direct response. 3.76e+04. What is the difference between the Emissions(kt) in Lower middle income in 2004 and the Emissions(kt) in Middle East & North Africa (developing only) in 2006?
Provide a succinct answer. 1.88e+06. What is the difference between the Emissions(kt) of Lower middle income in 2004 and the Emissions(kt) of Bangladesh in 2006?
Your answer should be compact. 2.95e+06. What is the difference between the Emissions(kt) of Lower middle income in 2004 and the Emissions(kt) of Gabon in 2006?
Offer a terse response. 3.00e+06. What is the difference between the Emissions(kt) in Middle East & North Africa (developing only) in 2004 and the Emissions(kt) in Bangladesh in 2006?
Give a very brief answer. 9.78e+05. What is the difference between the Emissions(kt) of Middle East & North Africa (developing only) in 2004 and the Emissions(kt) of Gabon in 2006?
Your answer should be compact. 1.02e+06. What is the difference between the Emissions(kt) in Bangladesh in 2004 and the Emissions(kt) in Gabon in 2006?
Offer a terse response. 3.77e+04. What is the difference between the Emissions(kt) in Lower middle income in 2005 and the Emissions(kt) in Middle East & North Africa (developing only) in 2006?
Offer a very short reply. 1.97e+06. What is the difference between the Emissions(kt) of Lower middle income in 2005 and the Emissions(kt) of Bangladesh in 2006?
Offer a very short reply. 3.05e+06. What is the difference between the Emissions(kt) in Lower middle income in 2005 and the Emissions(kt) in Gabon in 2006?
Make the answer very short. 3.09e+06. What is the difference between the Emissions(kt) of Middle East & North Africa (developing only) in 2005 and the Emissions(kt) of Bangladesh in 2006?
Make the answer very short. 1.04e+06. What is the difference between the Emissions(kt) of Middle East & North Africa (developing only) in 2005 and the Emissions(kt) of Gabon in 2006?
Ensure brevity in your answer.  1.09e+06. What is the difference between the Emissions(kt) of Bangladesh in 2005 and the Emissions(kt) of Gabon in 2006?
Make the answer very short. 3.55e+04. What is the average Emissions(kt) of Lower middle income per year?
Your answer should be compact. 2.83e+06. What is the average Emissions(kt) in Middle East & North Africa (developing only) per year?
Keep it short and to the point. 9.69e+05. What is the average Emissions(kt) in Bangladesh per year?
Provide a short and direct response. 3.48e+04. What is the average Emissions(kt) of Gabon per year?
Ensure brevity in your answer.  1700.11. In the year 1999, what is the difference between the Emissions(kt) in Lower middle income and Emissions(kt) in Middle East & North Africa (developing only)?
Keep it short and to the point. 1.61e+06. In the year 1999, what is the difference between the Emissions(kt) of Lower middle income and Emissions(kt) of Bangladesh?
Your response must be concise. 2.45e+06. In the year 1999, what is the difference between the Emissions(kt) of Lower middle income and Emissions(kt) of Gabon?
Your answer should be very brief. 2.47e+06. In the year 1999, what is the difference between the Emissions(kt) of Middle East & North Africa (developing only) and Emissions(kt) of Bangladesh?
Keep it short and to the point. 8.42e+05. In the year 1999, what is the difference between the Emissions(kt) of Middle East & North Africa (developing only) and Emissions(kt) of Gabon?
Your answer should be compact. 8.66e+05. In the year 1999, what is the difference between the Emissions(kt) of Bangladesh and Emissions(kt) of Gabon?
Your response must be concise. 2.38e+04. In the year 2000, what is the difference between the Emissions(kt) of Lower middle income and Emissions(kt) of Middle East & North Africa (developing only)?
Offer a terse response. 1.73e+06. In the year 2000, what is the difference between the Emissions(kt) in Lower middle income and Emissions(kt) in Bangladesh?
Your answer should be very brief. 2.57e+06. In the year 2000, what is the difference between the Emissions(kt) of Lower middle income and Emissions(kt) of Gabon?
Your answer should be compact. 2.60e+06. In the year 2000, what is the difference between the Emissions(kt) of Middle East & North Africa (developing only) and Emissions(kt) of Bangladesh?
Your answer should be compact. 8.45e+05. In the year 2000, what is the difference between the Emissions(kt) in Middle East & North Africa (developing only) and Emissions(kt) in Gabon?
Your answer should be very brief. 8.72e+05. In the year 2000, what is the difference between the Emissions(kt) in Bangladesh and Emissions(kt) in Gabon?
Keep it short and to the point. 2.68e+04. In the year 2001, what is the difference between the Emissions(kt) of Lower middle income and Emissions(kt) of Middle East & North Africa (developing only)?
Your answer should be very brief. 1.76e+06. In the year 2001, what is the difference between the Emissions(kt) in Lower middle income and Emissions(kt) in Bangladesh?
Ensure brevity in your answer.  2.63e+06. In the year 2001, what is the difference between the Emissions(kt) of Lower middle income and Emissions(kt) of Gabon?
Your answer should be compact. 2.66e+06. In the year 2001, what is the difference between the Emissions(kt) in Middle East & North Africa (developing only) and Emissions(kt) in Bangladesh?
Offer a very short reply. 8.67e+05. In the year 2001, what is the difference between the Emissions(kt) of Middle East & North Africa (developing only) and Emissions(kt) of Gabon?
Your answer should be very brief. 8.98e+05. In the year 2001, what is the difference between the Emissions(kt) in Bangladesh and Emissions(kt) in Gabon?
Your response must be concise. 3.07e+04. In the year 2002, what is the difference between the Emissions(kt) of Lower middle income and Emissions(kt) of Middle East & North Africa (developing only)?
Provide a short and direct response. 1.82e+06. In the year 2002, what is the difference between the Emissions(kt) in Lower middle income and Emissions(kt) in Bangladesh?
Provide a short and direct response. 2.69e+06. In the year 2002, what is the difference between the Emissions(kt) of Lower middle income and Emissions(kt) of Gabon?
Make the answer very short. 2.72e+06. In the year 2002, what is the difference between the Emissions(kt) of Middle East & North Africa (developing only) and Emissions(kt) of Bangladesh?
Give a very brief answer. 8.70e+05. In the year 2002, what is the difference between the Emissions(kt) in Middle East & North Africa (developing only) and Emissions(kt) in Gabon?
Your response must be concise. 9.02e+05. In the year 2002, what is the difference between the Emissions(kt) in Bangladesh and Emissions(kt) in Gabon?
Provide a succinct answer. 3.19e+04. In the year 2003, what is the difference between the Emissions(kt) of Lower middle income and Emissions(kt) of Middle East & North Africa (developing only)?
Offer a very short reply. 1.90e+06. In the year 2003, what is the difference between the Emissions(kt) in Lower middle income and Emissions(kt) in Bangladesh?
Your answer should be very brief. 2.84e+06. In the year 2003, what is the difference between the Emissions(kt) of Lower middle income and Emissions(kt) of Gabon?
Your answer should be very brief. 2.87e+06. In the year 2003, what is the difference between the Emissions(kt) of Middle East & North Africa (developing only) and Emissions(kt) of Bangladesh?
Ensure brevity in your answer.  9.34e+05. In the year 2003, what is the difference between the Emissions(kt) in Middle East & North Africa (developing only) and Emissions(kt) in Gabon?
Offer a very short reply. 9.66e+05. In the year 2003, what is the difference between the Emissions(kt) in Bangladesh and Emissions(kt) in Gabon?
Make the answer very short. 3.24e+04. In the year 2004, what is the difference between the Emissions(kt) of Lower middle income and Emissions(kt) of Middle East & North Africa (developing only)?
Ensure brevity in your answer.  1.98e+06. In the year 2004, what is the difference between the Emissions(kt) in Lower middle income and Emissions(kt) in Bangladesh?
Keep it short and to the point. 2.96e+06. In the year 2004, what is the difference between the Emissions(kt) in Lower middle income and Emissions(kt) in Gabon?
Provide a short and direct response. 3.00e+06. In the year 2004, what is the difference between the Emissions(kt) of Middle East & North Africa (developing only) and Emissions(kt) of Bangladesh?
Provide a succinct answer. 9.87e+05. In the year 2004, what is the difference between the Emissions(kt) in Middle East & North Africa (developing only) and Emissions(kt) in Gabon?
Offer a very short reply. 1.02e+06. In the year 2004, what is the difference between the Emissions(kt) of Bangladesh and Emissions(kt) of Gabon?
Offer a terse response. 3.79e+04. In the year 2005, what is the difference between the Emissions(kt) of Lower middle income and Emissions(kt) of Middle East & North Africa (developing only)?
Keep it short and to the point. 2.00e+06. In the year 2005, what is the difference between the Emissions(kt) of Lower middle income and Emissions(kt) of Bangladesh?
Keep it short and to the point. 3.06e+06. In the year 2005, what is the difference between the Emissions(kt) in Lower middle income and Emissions(kt) in Gabon?
Keep it short and to the point. 3.09e+06. In the year 2005, what is the difference between the Emissions(kt) of Middle East & North Africa (developing only) and Emissions(kt) of Bangladesh?
Your answer should be very brief. 1.05e+06. In the year 2005, what is the difference between the Emissions(kt) in Middle East & North Africa (developing only) and Emissions(kt) in Gabon?
Your answer should be compact. 1.09e+06. In the year 2005, what is the difference between the Emissions(kt) in Bangladesh and Emissions(kt) in Gabon?
Provide a succinct answer. 3.54e+04. In the year 2006, what is the difference between the Emissions(kt) of Lower middle income and Emissions(kt) of Middle East & North Africa (developing only)?
Offer a very short reply. 2.10e+06. In the year 2006, what is the difference between the Emissions(kt) in Lower middle income and Emissions(kt) in Bangladesh?
Make the answer very short. 3.17e+06. In the year 2006, what is the difference between the Emissions(kt) in Lower middle income and Emissions(kt) in Gabon?
Your answer should be compact. 3.22e+06. In the year 2006, what is the difference between the Emissions(kt) in Middle East & North Africa (developing only) and Emissions(kt) in Bangladesh?
Make the answer very short. 1.08e+06. In the year 2006, what is the difference between the Emissions(kt) in Middle East & North Africa (developing only) and Emissions(kt) in Gabon?
Provide a succinct answer. 1.12e+06. In the year 2006, what is the difference between the Emissions(kt) of Bangladesh and Emissions(kt) of Gabon?
Offer a very short reply. 4.61e+04. What is the ratio of the Emissions(kt) of Lower middle income in 1999 to that in 2000?
Make the answer very short. 0.95. What is the ratio of the Emissions(kt) of Middle East & North Africa (developing only) in 1999 to that in 2000?
Your answer should be compact. 0.99. What is the ratio of the Emissions(kt) in Bangladesh in 1999 to that in 2000?
Provide a short and direct response. 0.91. What is the ratio of the Emissions(kt) of Gabon in 1999 to that in 2000?
Your answer should be compact. 1.37. What is the ratio of the Emissions(kt) in Lower middle income in 1999 to that in 2001?
Your answer should be very brief. 0.93. What is the ratio of the Emissions(kt) of Middle East & North Africa (developing only) in 1999 to that in 2001?
Provide a succinct answer. 0.96. What is the ratio of the Emissions(kt) of Bangladesh in 1999 to that in 2001?
Keep it short and to the point. 0.78. What is the ratio of the Emissions(kt) in Gabon in 1999 to that in 2001?
Your response must be concise. 0.81. What is the ratio of the Emissions(kt) in Lower middle income in 1999 to that in 2002?
Provide a short and direct response. 0.91. What is the ratio of the Emissions(kt) of Middle East & North Africa (developing only) in 1999 to that in 2002?
Keep it short and to the point. 0.96. What is the ratio of the Emissions(kt) of Bangladesh in 1999 to that in 2002?
Provide a succinct answer. 0.75. What is the ratio of the Emissions(kt) of Gabon in 1999 to that in 2002?
Your answer should be compact. 0.81. What is the ratio of the Emissions(kt) in Lower middle income in 1999 to that in 2003?
Provide a succinct answer. 0.86. What is the ratio of the Emissions(kt) in Middle East & North Africa (developing only) in 1999 to that in 2003?
Provide a succinct answer. 0.9. What is the ratio of the Emissions(kt) of Bangladesh in 1999 to that in 2003?
Keep it short and to the point. 0.74. What is the ratio of the Emissions(kt) in Lower middle income in 1999 to that in 2004?
Give a very brief answer. 0.82. What is the ratio of the Emissions(kt) of Middle East & North Africa (developing only) in 1999 to that in 2004?
Offer a terse response. 0.84. What is the ratio of the Emissions(kt) in Bangladesh in 1999 to that in 2004?
Your answer should be compact. 0.63. What is the ratio of the Emissions(kt) of Gabon in 1999 to that in 2004?
Provide a short and direct response. 0.78. What is the ratio of the Emissions(kt) in Lower middle income in 1999 to that in 2005?
Make the answer very short. 0.8. What is the ratio of the Emissions(kt) in Middle East & North Africa (developing only) in 1999 to that in 2005?
Ensure brevity in your answer.  0.8. What is the ratio of the Emissions(kt) of Bangladesh in 1999 to that in 2005?
Ensure brevity in your answer.  0.67. What is the ratio of the Emissions(kt) in Gabon in 1999 to that in 2005?
Offer a very short reply. 0.66. What is the ratio of the Emissions(kt) in Lower middle income in 1999 to that in 2006?
Your answer should be compact. 0.77. What is the ratio of the Emissions(kt) of Middle East & North Africa (developing only) in 1999 to that in 2006?
Ensure brevity in your answer.  0.77. What is the ratio of the Emissions(kt) in Bangladesh in 1999 to that in 2006?
Keep it short and to the point. 0.52. What is the ratio of the Emissions(kt) of Gabon in 1999 to that in 2006?
Offer a very short reply. 0.69. What is the ratio of the Emissions(kt) of Lower middle income in 2000 to that in 2001?
Make the answer very short. 0.98. What is the ratio of the Emissions(kt) in Middle East & North Africa (developing only) in 2000 to that in 2001?
Ensure brevity in your answer.  0.97. What is the ratio of the Emissions(kt) in Bangladesh in 2000 to that in 2001?
Your answer should be very brief. 0.86. What is the ratio of the Emissions(kt) in Gabon in 2000 to that in 2001?
Provide a succinct answer. 0.59. What is the ratio of the Emissions(kt) of Lower middle income in 2000 to that in 2002?
Give a very brief answer. 0.96. What is the ratio of the Emissions(kt) of Bangladesh in 2000 to that in 2002?
Keep it short and to the point. 0.83. What is the ratio of the Emissions(kt) of Gabon in 2000 to that in 2002?
Provide a short and direct response. 0.59. What is the ratio of the Emissions(kt) of Lower middle income in 2000 to that in 2003?
Ensure brevity in your answer.  0.91. What is the ratio of the Emissions(kt) of Middle East & North Africa (developing only) in 2000 to that in 2003?
Your answer should be compact. 0.9. What is the ratio of the Emissions(kt) of Bangladesh in 2000 to that in 2003?
Your answer should be compact. 0.82. What is the ratio of the Emissions(kt) in Gabon in 2000 to that in 2003?
Give a very brief answer. 0.73. What is the ratio of the Emissions(kt) in Lower middle income in 2000 to that in 2004?
Offer a very short reply. 0.87. What is the ratio of the Emissions(kt) of Middle East & North Africa (developing only) in 2000 to that in 2004?
Offer a very short reply. 0.85. What is the ratio of the Emissions(kt) in Bangladesh in 2000 to that in 2004?
Keep it short and to the point. 0.7. What is the ratio of the Emissions(kt) of Gabon in 2000 to that in 2004?
Your answer should be compact. 0.57. What is the ratio of the Emissions(kt) in Lower middle income in 2000 to that in 2005?
Ensure brevity in your answer.  0.84. What is the ratio of the Emissions(kt) in Middle East & North Africa (developing only) in 2000 to that in 2005?
Offer a very short reply. 0.8. What is the ratio of the Emissions(kt) in Bangladesh in 2000 to that in 2005?
Your response must be concise. 0.74. What is the ratio of the Emissions(kt) of Gabon in 2000 to that in 2005?
Offer a terse response. 0.48. What is the ratio of the Emissions(kt) in Lower middle income in 2000 to that in 2006?
Make the answer very short. 0.81. What is the ratio of the Emissions(kt) in Middle East & North Africa (developing only) in 2000 to that in 2006?
Offer a very short reply. 0.78. What is the ratio of the Emissions(kt) in Bangladesh in 2000 to that in 2006?
Offer a terse response. 0.58. What is the ratio of the Emissions(kt) of Gabon in 2000 to that in 2006?
Your response must be concise. 0.51. What is the ratio of the Emissions(kt) in Lower middle income in 2001 to that in 2002?
Give a very brief answer. 0.98. What is the ratio of the Emissions(kt) of Middle East & North Africa (developing only) in 2001 to that in 2002?
Provide a succinct answer. 1. What is the ratio of the Emissions(kt) in Bangladesh in 2001 to that in 2002?
Provide a short and direct response. 0.96. What is the ratio of the Emissions(kt) of Gabon in 2001 to that in 2002?
Make the answer very short. 1. What is the ratio of the Emissions(kt) in Lower middle income in 2001 to that in 2003?
Your answer should be very brief. 0.93. What is the ratio of the Emissions(kt) of Middle East & North Africa (developing only) in 2001 to that in 2003?
Your answer should be compact. 0.93. What is the ratio of the Emissions(kt) of Bangladesh in 2001 to that in 2003?
Offer a terse response. 0.96. What is the ratio of the Emissions(kt) in Gabon in 2001 to that in 2003?
Your answer should be compact. 1.24. What is the ratio of the Emissions(kt) in Lower middle income in 2001 to that in 2004?
Your answer should be compact. 0.89. What is the ratio of the Emissions(kt) of Middle East & North Africa (developing only) in 2001 to that in 2004?
Your answer should be very brief. 0.88. What is the ratio of the Emissions(kt) of Bangladesh in 2001 to that in 2004?
Provide a short and direct response. 0.82. What is the ratio of the Emissions(kt) of Gabon in 2001 to that in 2004?
Keep it short and to the point. 0.96. What is the ratio of the Emissions(kt) of Lower middle income in 2001 to that in 2005?
Provide a succinct answer. 0.86. What is the ratio of the Emissions(kt) of Middle East & North Africa (developing only) in 2001 to that in 2005?
Offer a very short reply. 0.83. What is the ratio of the Emissions(kt) of Bangladesh in 2001 to that in 2005?
Offer a very short reply. 0.86. What is the ratio of the Emissions(kt) of Gabon in 2001 to that in 2005?
Provide a succinct answer. 0.82. What is the ratio of the Emissions(kt) in Lower middle income in 2001 to that in 2006?
Provide a succinct answer. 0.83. What is the ratio of the Emissions(kt) in Middle East & North Africa (developing only) in 2001 to that in 2006?
Ensure brevity in your answer.  0.8. What is the ratio of the Emissions(kt) of Bangladesh in 2001 to that in 2006?
Provide a succinct answer. 0.67. What is the ratio of the Emissions(kt) in Gabon in 2001 to that in 2006?
Offer a very short reply. 0.86. What is the ratio of the Emissions(kt) of Lower middle income in 2002 to that in 2003?
Ensure brevity in your answer.  0.95. What is the ratio of the Emissions(kt) of Middle East & North Africa (developing only) in 2002 to that in 2003?
Your answer should be compact. 0.93. What is the ratio of the Emissions(kt) in Gabon in 2002 to that in 2003?
Make the answer very short. 1.23. What is the ratio of the Emissions(kt) of Lower middle income in 2002 to that in 2004?
Ensure brevity in your answer.  0.91. What is the ratio of the Emissions(kt) in Middle East & North Africa (developing only) in 2002 to that in 2004?
Offer a very short reply. 0.88. What is the ratio of the Emissions(kt) in Bangladesh in 2002 to that in 2004?
Your answer should be very brief. 0.85. What is the ratio of the Emissions(kt) in Gabon in 2002 to that in 2004?
Provide a short and direct response. 0.96. What is the ratio of the Emissions(kt) in Lower middle income in 2002 to that in 2005?
Your answer should be very brief. 0.88. What is the ratio of the Emissions(kt) in Middle East & North Africa (developing only) in 2002 to that in 2005?
Provide a short and direct response. 0.83. What is the ratio of the Emissions(kt) in Bangladesh in 2002 to that in 2005?
Offer a very short reply. 0.9. What is the ratio of the Emissions(kt) in Gabon in 2002 to that in 2005?
Provide a short and direct response. 0.82. What is the ratio of the Emissions(kt) of Lower middle income in 2002 to that in 2006?
Give a very brief answer. 0.84. What is the ratio of the Emissions(kt) in Middle East & North Africa (developing only) in 2002 to that in 2006?
Provide a succinct answer. 0.8. What is the ratio of the Emissions(kt) in Bangladesh in 2002 to that in 2006?
Your answer should be compact. 0.7. What is the ratio of the Emissions(kt) in Gabon in 2002 to that in 2006?
Keep it short and to the point. 0.85. What is the ratio of the Emissions(kt) in Lower middle income in 2003 to that in 2004?
Your response must be concise. 0.96. What is the ratio of the Emissions(kt) of Middle East & North Africa (developing only) in 2003 to that in 2004?
Offer a very short reply. 0.94. What is the ratio of the Emissions(kt) in Bangladesh in 2003 to that in 2004?
Your answer should be very brief. 0.85. What is the ratio of the Emissions(kt) of Gabon in 2003 to that in 2004?
Give a very brief answer. 0.78. What is the ratio of the Emissions(kt) in Lower middle income in 2003 to that in 2005?
Provide a succinct answer. 0.93. What is the ratio of the Emissions(kt) of Middle East & North Africa (developing only) in 2003 to that in 2005?
Make the answer very short. 0.89. What is the ratio of the Emissions(kt) of Bangladesh in 2003 to that in 2005?
Your answer should be compact. 0.9. What is the ratio of the Emissions(kt) in Gabon in 2003 to that in 2005?
Ensure brevity in your answer.  0.66. What is the ratio of the Emissions(kt) of Lower middle income in 2003 to that in 2006?
Keep it short and to the point. 0.89. What is the ratio of the Emissions(kt) of Middle East & North Africa (developing only) in 2003 to that in 2006?
Offer a very short reply. 0.86. What is the ratio of the Emissions(kt) of Bangladesh in 2003 to that in 2006?
Your answer should be compact. 0.7. What is the ratio of the Emissions(kt) in Gabon in 2003 to that in 2006?
Make the answer very short. 0.69. What is the ratio of the Emissions(kt) of Lower middle income in 2004 to that in 2005?
Provide a short and direct response. 0.97. What is the ratio of the Emissions(kt) of Middle East & North Africa (developing only) in 2004 to that in 2005?
Your answer should be very brief. 0.94. What is the ratio of the Emissions(kt) in Bangladesh in 2004 to that in 2005?
Keep it short and to the point. 1.06. What is the ratio of the Emissions(kt) of Gabon in 2004 to that in 2005?
Your answer should be very brief. 0.85. What is the ratio of the Emissions(kt) in Lower middle income in 2004 to that in 2006?
Your response must be concise. 0.93. What is the ratio of the Emissions(kt) in Middle East & North Africa (developing only) in 2004 to that in 2006?
Make the answer very short. 0.91. What is the ratio of the Emissions(kt) in Bangladesh in 2004 to that in 2006?
Your answer should be very brief. 0.83. What is the ratio of the Emissions(kt) of Gabon in 2004 to that in 2006?
Provide a succinct answer. 0.89. What is the ratio of the Emissions(kt) of Lower middle income in 2005 to that in 2006?
Your response must be concise. 0.96. What is the ratio of the Emissions(kt) in Middle East & North Africa (developing only) in 2005 to that in 2006?
Your answer should be compact. 0.97. What is the ratio of the Emissions(kt) of Bangladesh in 2005 to that in 2006?
Offer a terse response. 0.78. What is the ratio of the Emissions(kt) of Gabon in 2005 to that in 2006?
Give a very brief answer. 1.04. What is the difference between the highest and the second highest Emissions(kt) of Lower middle income?
Keep it short and to the point. 1.29e+05. What is the difference between the highest and the second highest Emissions(kt) in Middle East & North Africa (developing only)?
Keep it short and to the point. 3.69e+04. What is the difference between the highest and the second highest Emissions(kt) of Bangladesh?
Your answer should be compact. 8386.43. What is the difference between the highest and the second highest Emissions(kt) in Gabon?
Your response must be concise. 91.67. What is the difference between the highest and the lowest Emissions(kt) in Lower middle income?
Your answer should be compact. 7.48e+05. What is the difference between the highest and the lowest Emissions(kt) of Middle East & North Africa (developing only)?
Offer a terse response. 2.59e+05. What is the difference between the highest and the lowest Emissions(kt) in Bangladesh?
Provide a succinct answer. 2.29e+04. What is the difference between the highest and the lowest Emissions(kt) of Gabon?
Your response must be concise. 1122.1. 